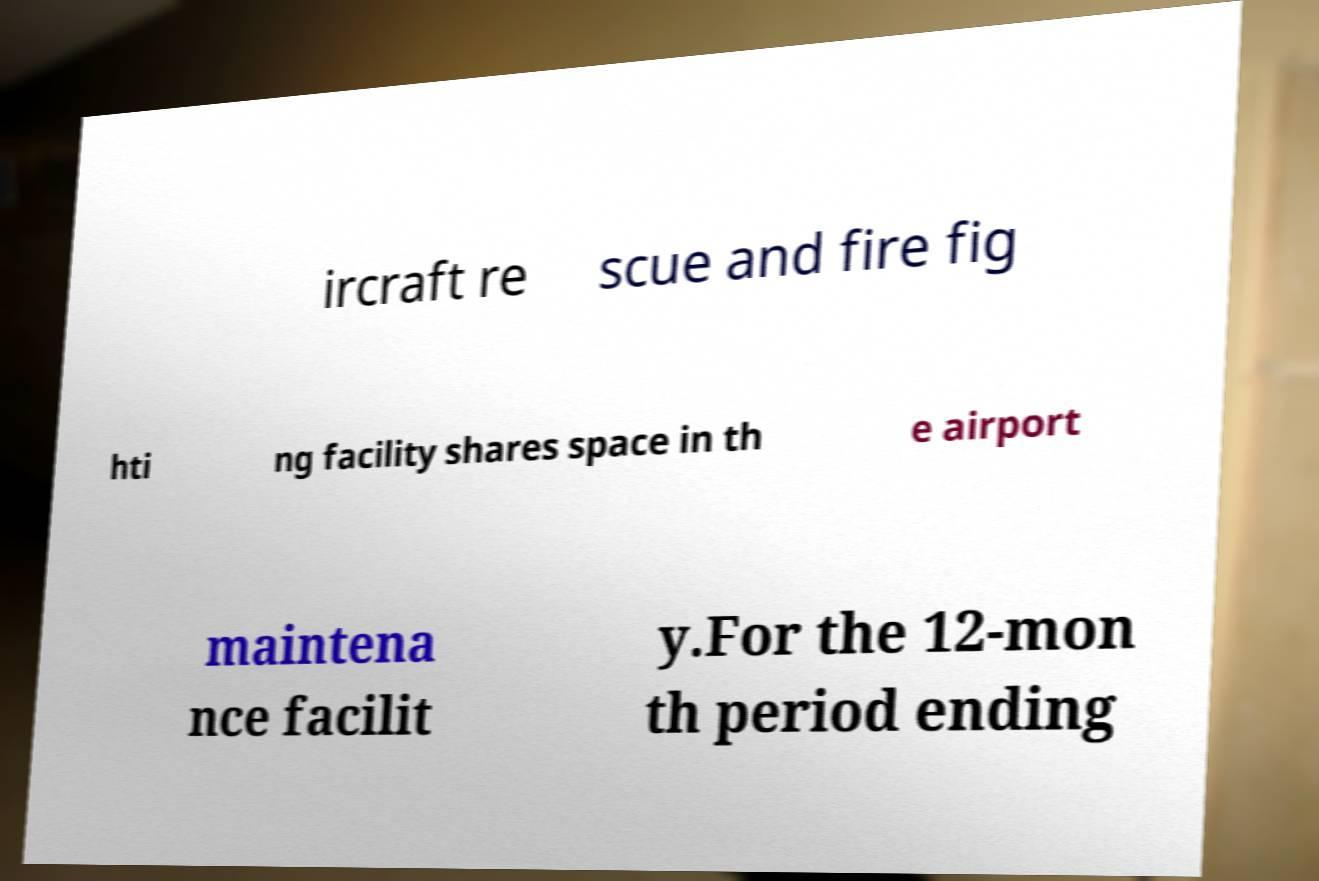Could you extract and type out the text from this image? ircraft re scue and fire fig hti ng facility shares space in th e airport maintena nce facilit y.For the 12-mon th period ending 